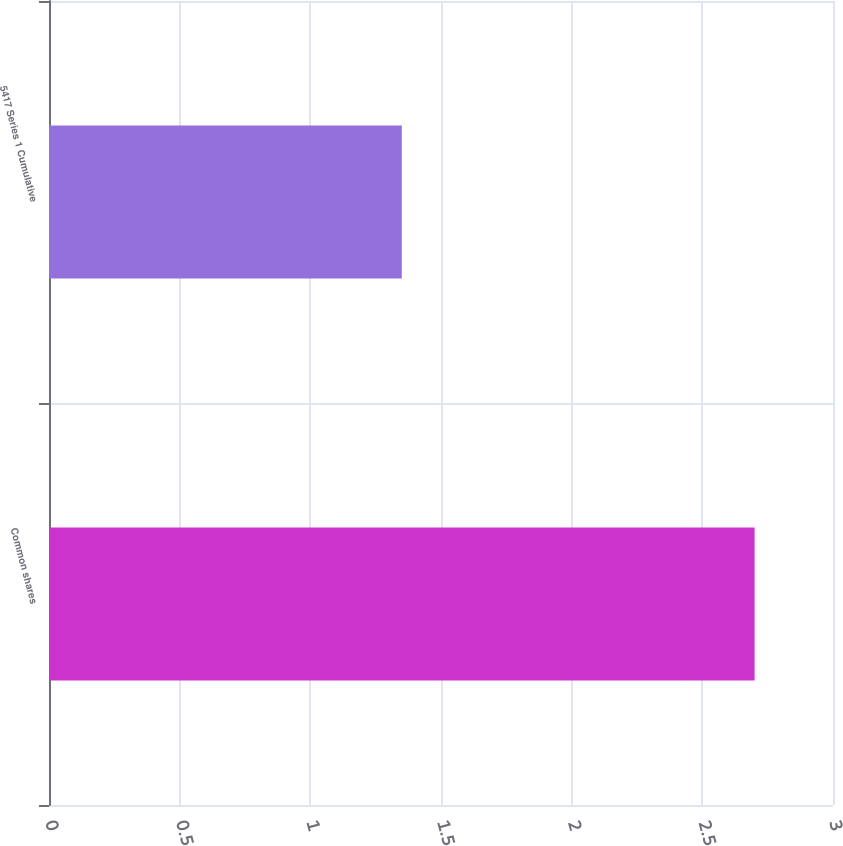Convert chart. <chart><loc_0><loc_0><loc_500><loc_500><bar_chart><fcel>Common shares<fcel>5417 Series 1 Cumulative<nl><fcel>2.7<fcel>1.35<nl></chart> 